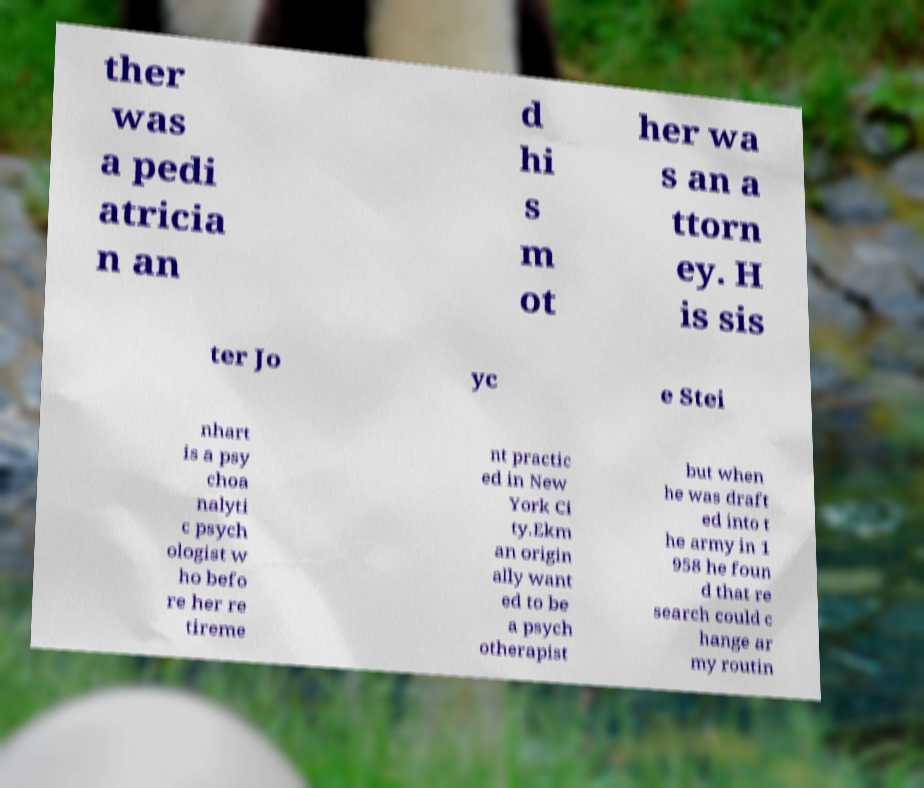Could you assist in decoding the text presented in this image and type it out clearly? ther was a pedi atricia n an d hi s m ot her wa s an a ttorn ey. H is sis ter Jo yc e Stei nhart is a psy choa nalyti c psych ologist w ho befo re her re tireme nt practic ed in New York Ci ty.Ekm an origin ally want ed to be a psych otherapist but when he was draft ed into t he army in 1 958 he foun d that re search could c hange ar my routin 